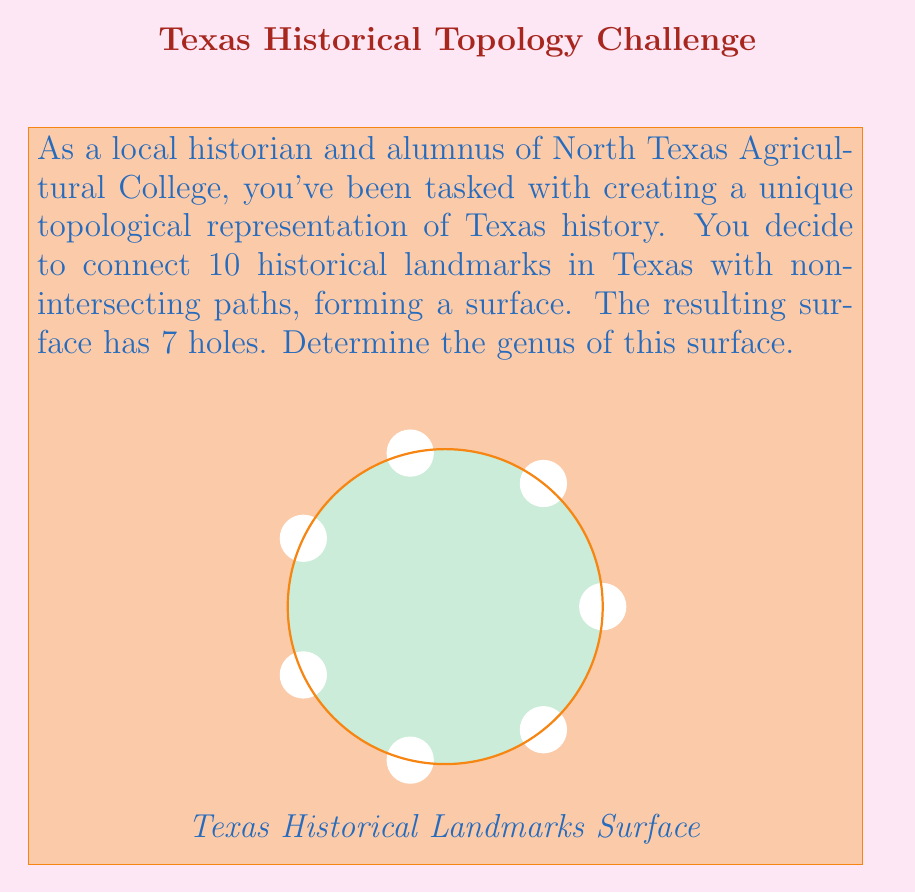Solve this math problem. To determine the genus of the surface, we'll follow these steps:

1) Recall the Euler characteristic formula for a closed surface:

   $$\chi = V - E + F = 2 - 2g$$

   where $\chi$ is the Euler characteristic, $V$ is the number of vertices, $E$ is the number of edges, $F$ is the number of faces, and $g$ is the genus.

2) In our case:
   - We have 10 landmarks, so $V = 10$
   - The landmarks are connected by non-intersecting paths, forming a single face with 7 holes. So $F = 1$
   - To calculate $E$, we can use the fact that in a planar graph, $E = V + F - 2 + 2g$

3) Substituting what we know into the Euler characteristic formula:

   $$\chi = 10 - E + 1 = 2 - 2g$$

4) Now, using the planar graph formula for $E$:

   $$E = 10 + 1 - 2 + 2g = 9 + 2g$$

5) Substituting this back into the Euler characteristic equation:

   $$10 - (9 + 2g) + 1 = 2 - 2g$$
   $$2 - 2g = 2 - 2g$$

6) This equation is true for any value of $g$. To determine $g$, we need to use the additional information that the surface has 7 holes.

7) In topology, the number of holes in a surface is equal to its genus. Therefore, $g = 7$.
Answer: $g = 7$ 